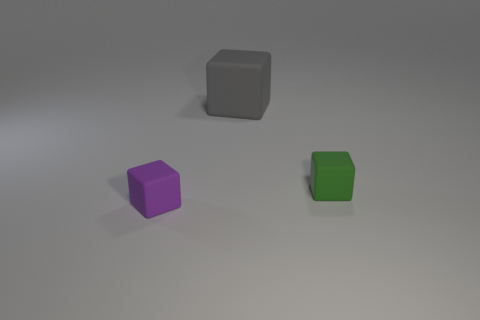What is the tiny green block made of? While I can't interact with the object to determine its material with absolute certainty, the tiny green block appears to be a computer-generated image with a surface texture that might suggest it's made of plastic or a similarly smooth material, commonly used in simple 3D models for illustration purposes. 